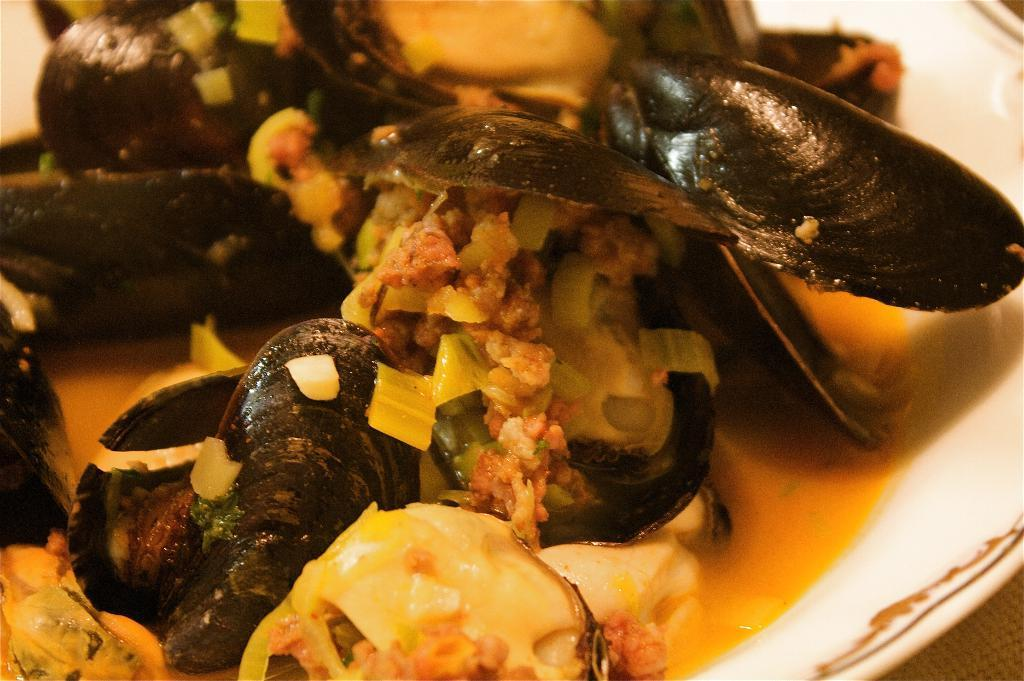What is on the plate in the image? There is food on a plate in the image. How many matches are on the plate in the image? There are no matches present on the plate in the image. 